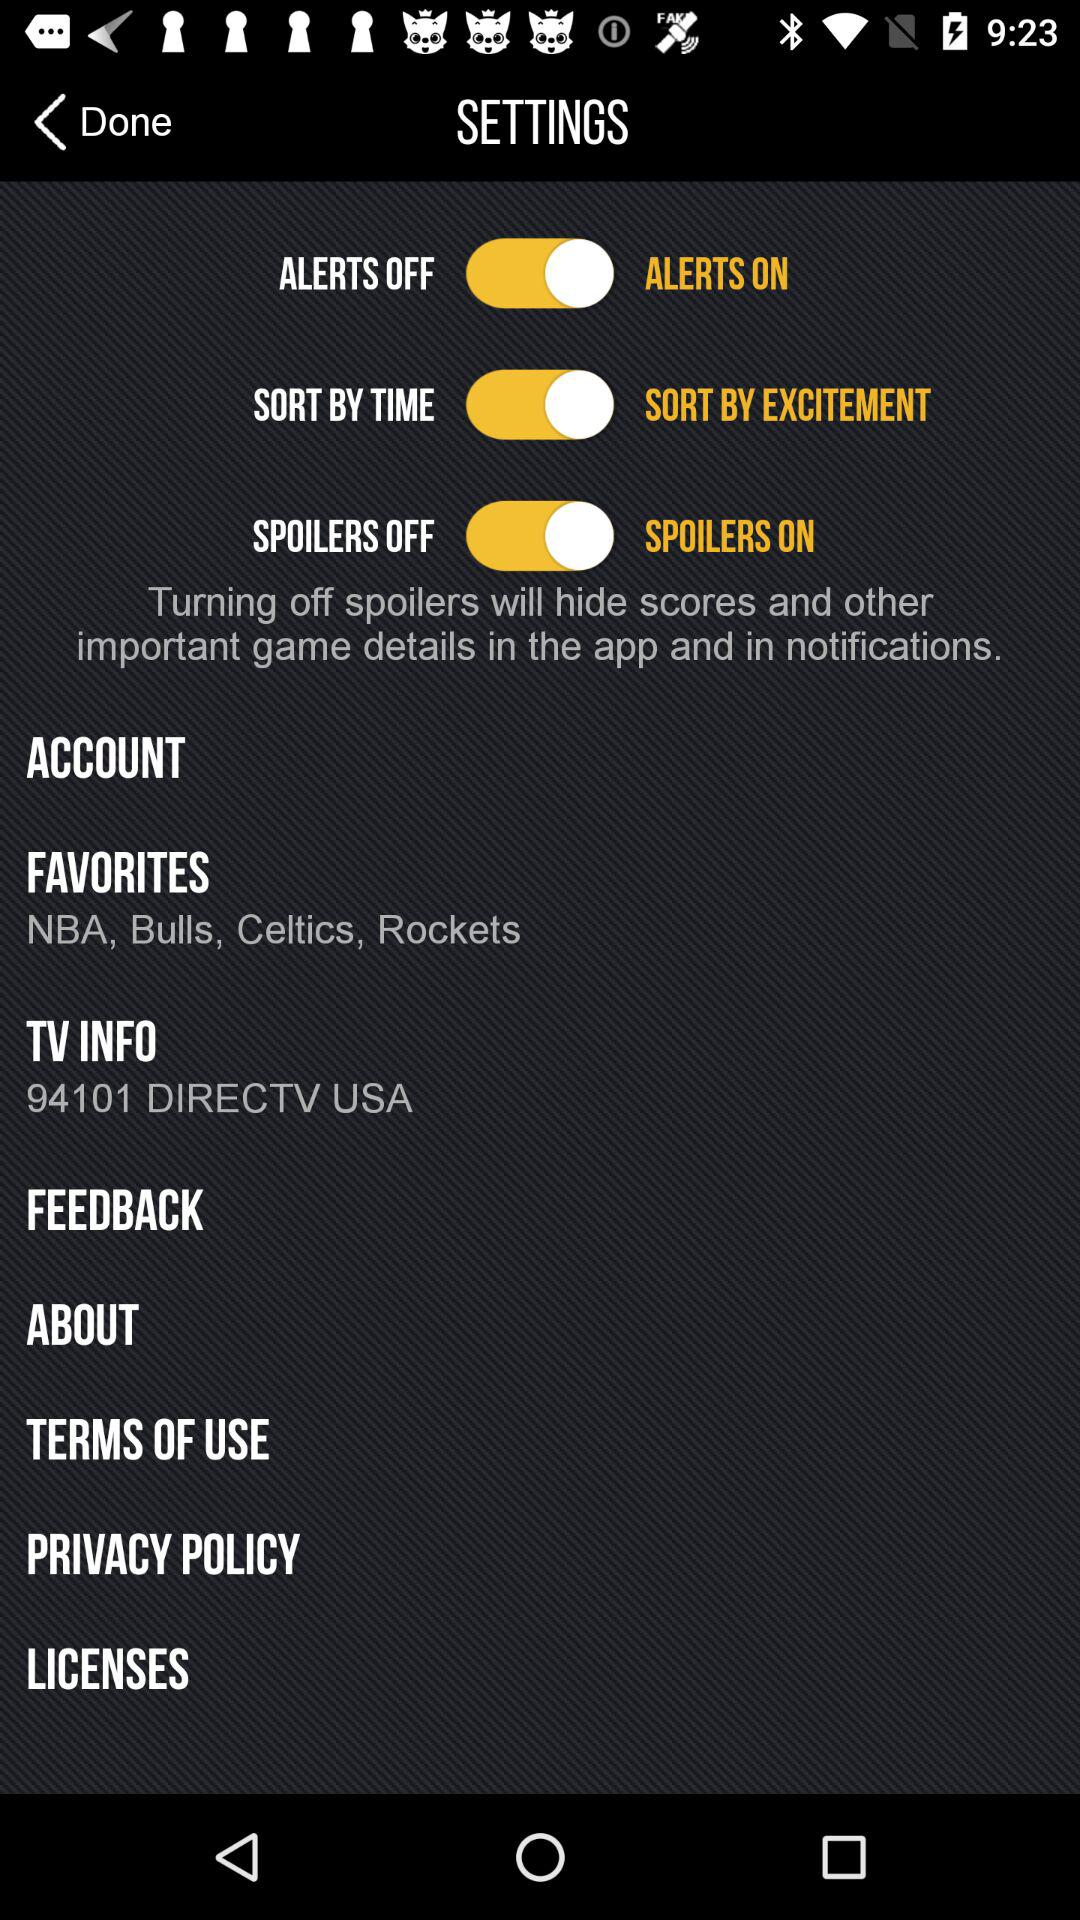What is the "TV INFO"? The "TV INFO" is 94101 DIRECTV USA. 